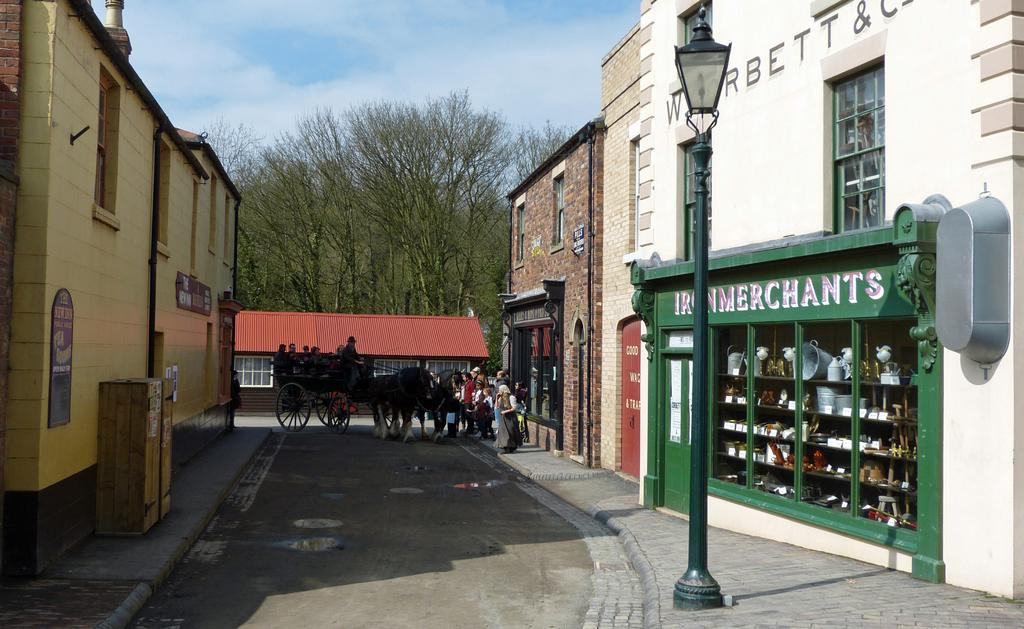<image>
Summarize the visual content of the image. A group of shops and a sign that says iron merchants in white writing. 